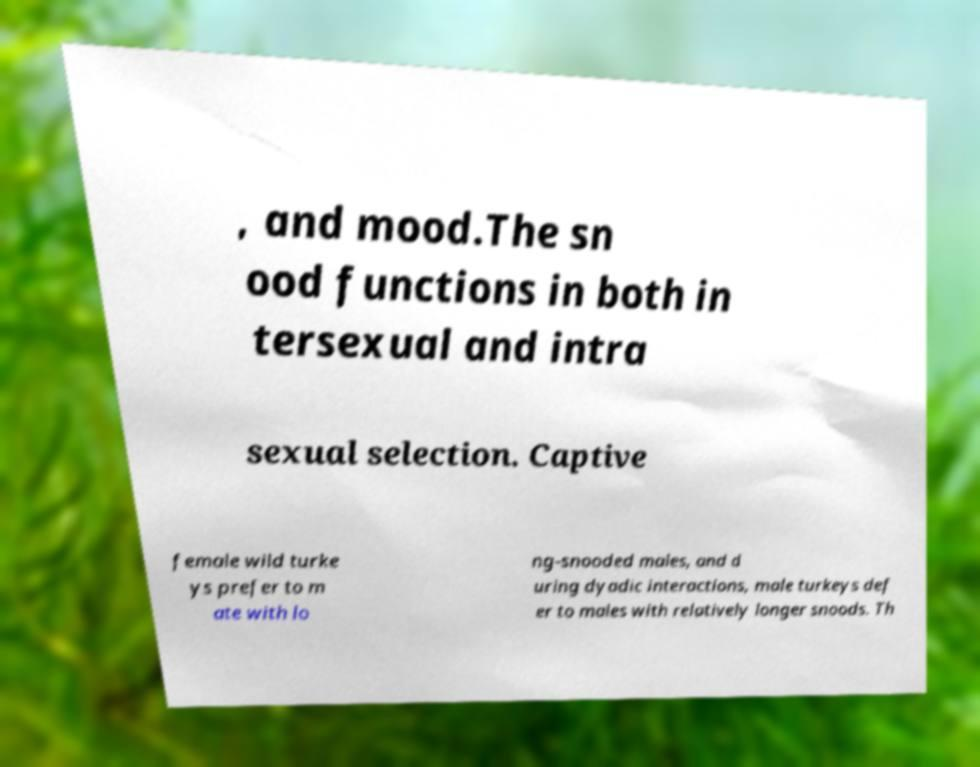What messages or text are displayed in this image? I need them in a readable, typed format. , and mood.The sn ood functions in both in tersexual and intra sexual selection. Captive female wild turke ys prefer to m ate with lo ng-snooded males, and d uring dyadic interactions, male turkeys def er to males with relatively longer snoods. Th 